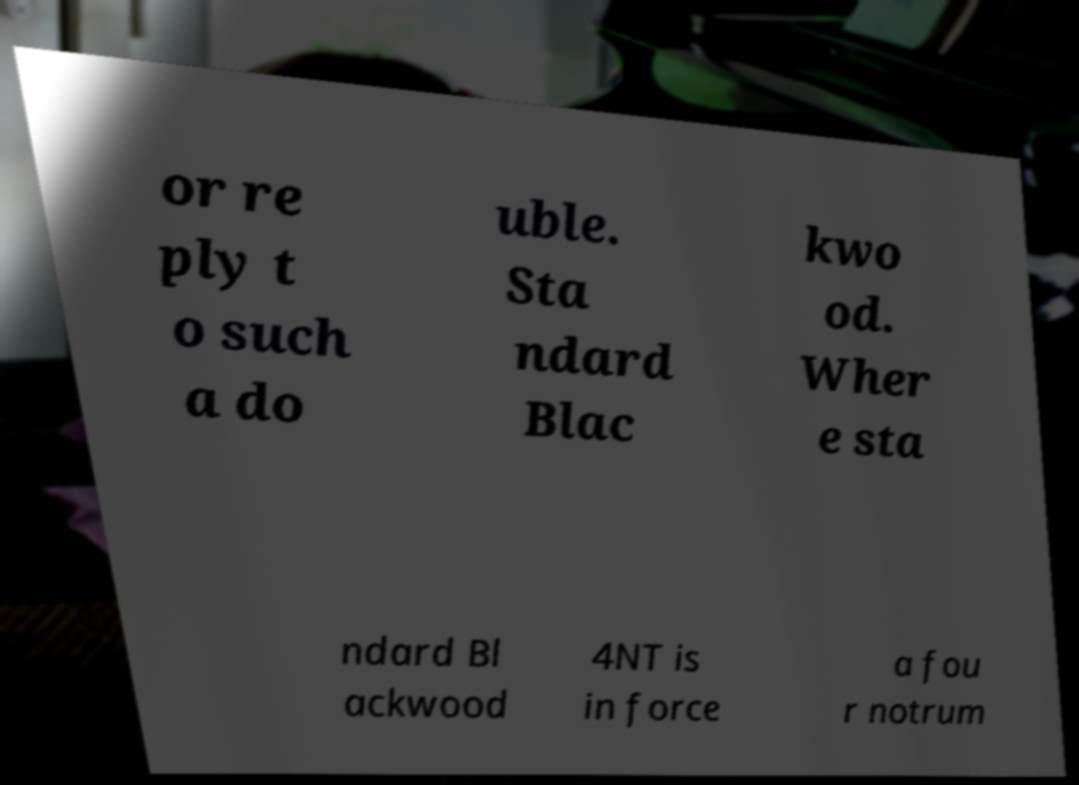For documentation purposes, I need the text within this image transcribed. Could you provide that? or re ply t o such a do uble. Sta ndard Blac kwo od. Wher e sta ndard Bl ackwood 4NT is in force a fou r notrum 